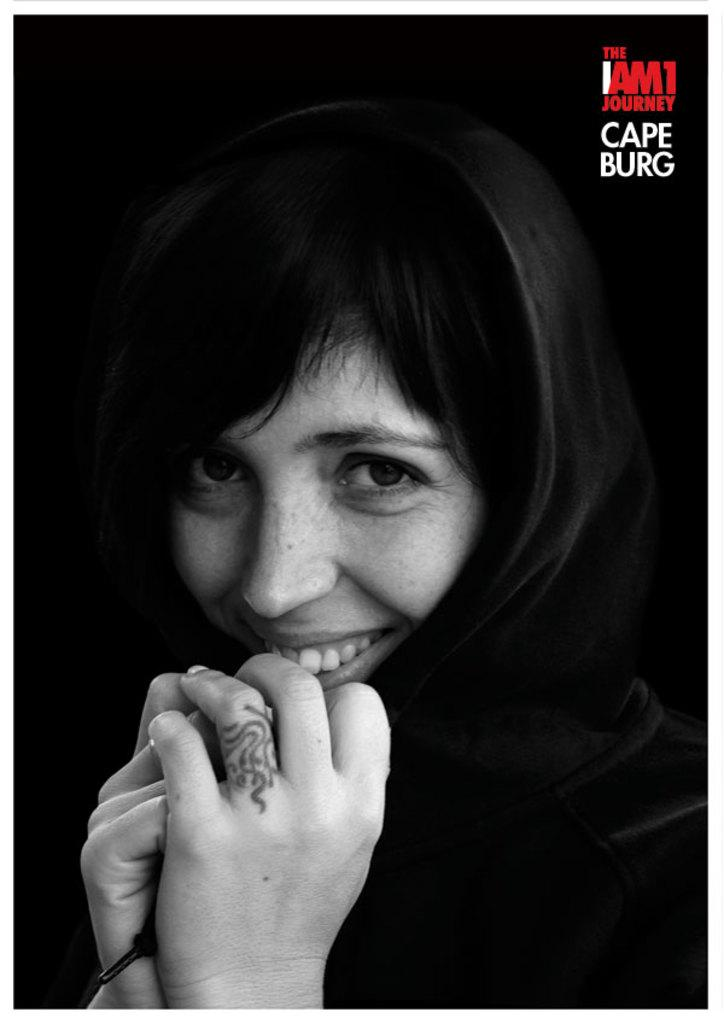What is the main subject of the image? There is a person in the image. What is the person doing in the image? The person is smiling. What is the person holding in the image? The person is holding an object with both hands. Can you describe the background of the image? The background of the image is dark in color. How many lines can be seen in the image? There is no mention of lines in the provided facts, so it is impossible to determine the number of lines in the image. 